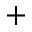<formula> <loc_0><loc_0><loc_500><loc_500>+</formula> 